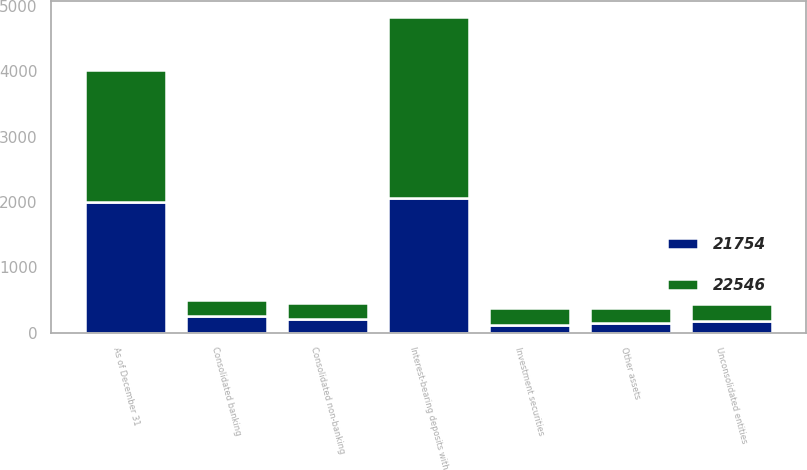Convert chart to OTSL. <chart><loc_0><loc_0><loc_500><loc_500><stacked_bar_chart><ecel><fcel>As of December 31<fcel>Interest-bearing deposits with<fcel>Investment securities<fcel>Consolidated banking<fcel>Consolidated non-banking<fcel>Unconsolidated entities<fcel>Other assets<nl><fcel>22546<fcel>2008<fcel>2770<fcel>256<fcel>254<fcel>239<fcel>252<fcel>229<nl><fcel>21754<fcel>2007<fcel>2067<fcel>122<fcel>254<fcel>210<fcel>184<fcel>149<nl></chart> 